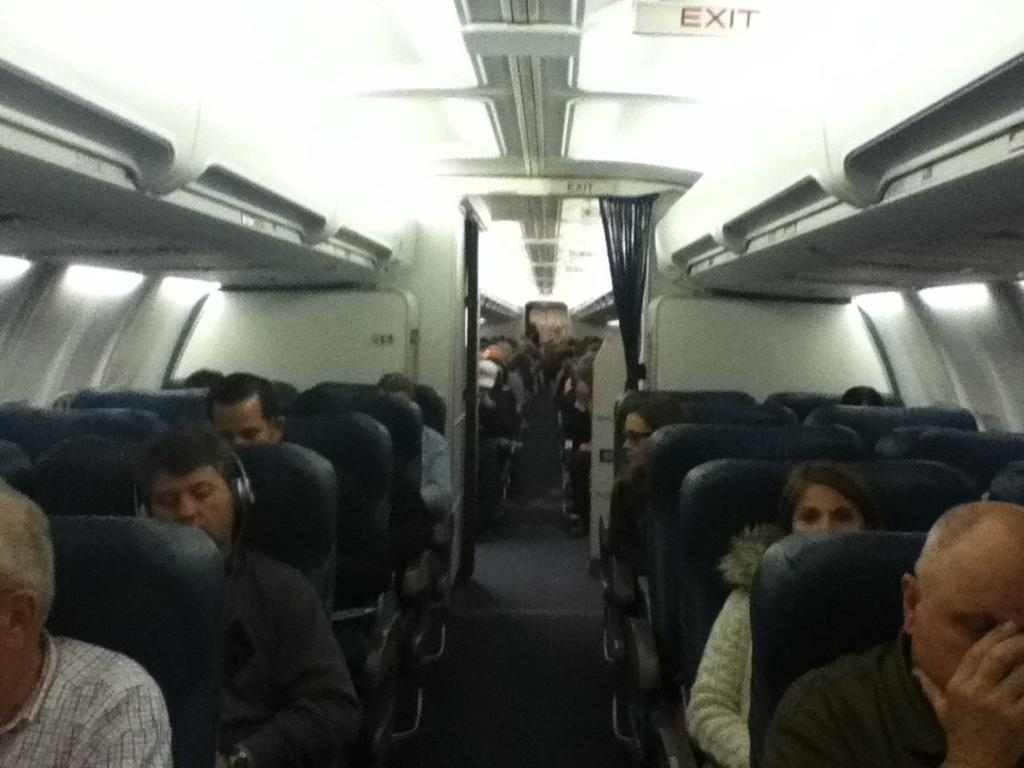What type of location is depicted in the image? The image is an inside view of a plane. What are the people in the image doing? The people in the image are sitting on chairs. What can be seen on the roof of the plane? There are lights on the roof. Where is the exit information located in the image? There is an exit board visible in the image. What type of window treatment is present in the image? There are curtains present in the image. How many ladybugs can be seen crawling on the exit board in the image? There are no ladybugs present in the image; it is an inside view of a plane with an exit board. What type of credit card is accepted by the airline in the image? There is no mention of credit cards or payment methods in the image; it only shows the inside of a plane with people sitting on chairs, lights on the roof, an exit board, and curtains. 